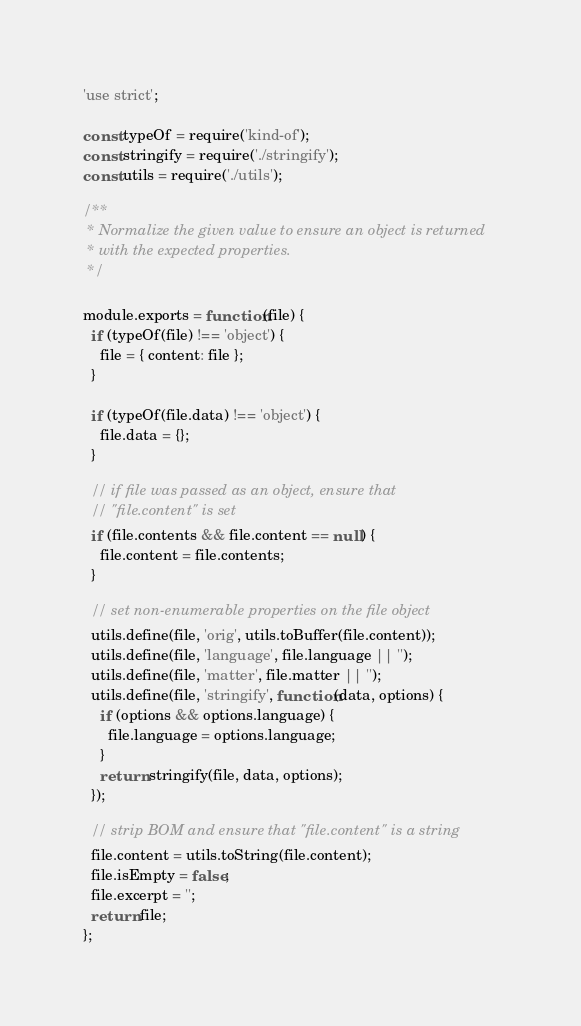Convert code to text. <code><loc_0><loc_0><loc_500><loc_500><_JavaScript_>'use strict';

const typeOf = require('kind-of');
const stringify = require('./stringify');
const utils = require('./utils');

/**
 * Normalize the given value to ensure an object is returned
 * with the expected properties.
 */

module.exports = function(file) {
  if (typeOf(file) !== 'object') {
    file = { content: file };
  }

  if (typeOf(file.data) !== 'object') {
    file.data = {};
  }

  // if file was passed as an object, ensure that
  // "file.content" is set
  if (file.contents && file.content == null) {
    file.content = file.contents;
  }

  // set non-enumerable properties on the file object
  utils.define(file, 'orig', utils.toBuffer(file.content));
  utils.define(file, 'language', file.language || '');
  utils.define(file, 'matter', file.matter || '');
  utils.define(file, 'stringify', function(data, options) {
    if (options && options.language) {
      file.language = options.language;
    }
    return stringify(file, data, options);
  });

  // strip BOM and ensure that "file.content" is a string
  file.content = utils.toString(file.content);
  file.isEmpty = false;
  file.excerpt = '';
  return file;
};
</code> 